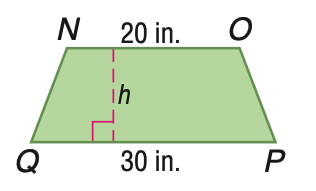Answer the mathemtical geometry problem and directly provide the correct option letter.
Question: Trapezoid N O P Q has an area of 250 square inches. Find the height of N O P Q.
Choices: A: 10 B: 15 C: 20 D: 25 A 